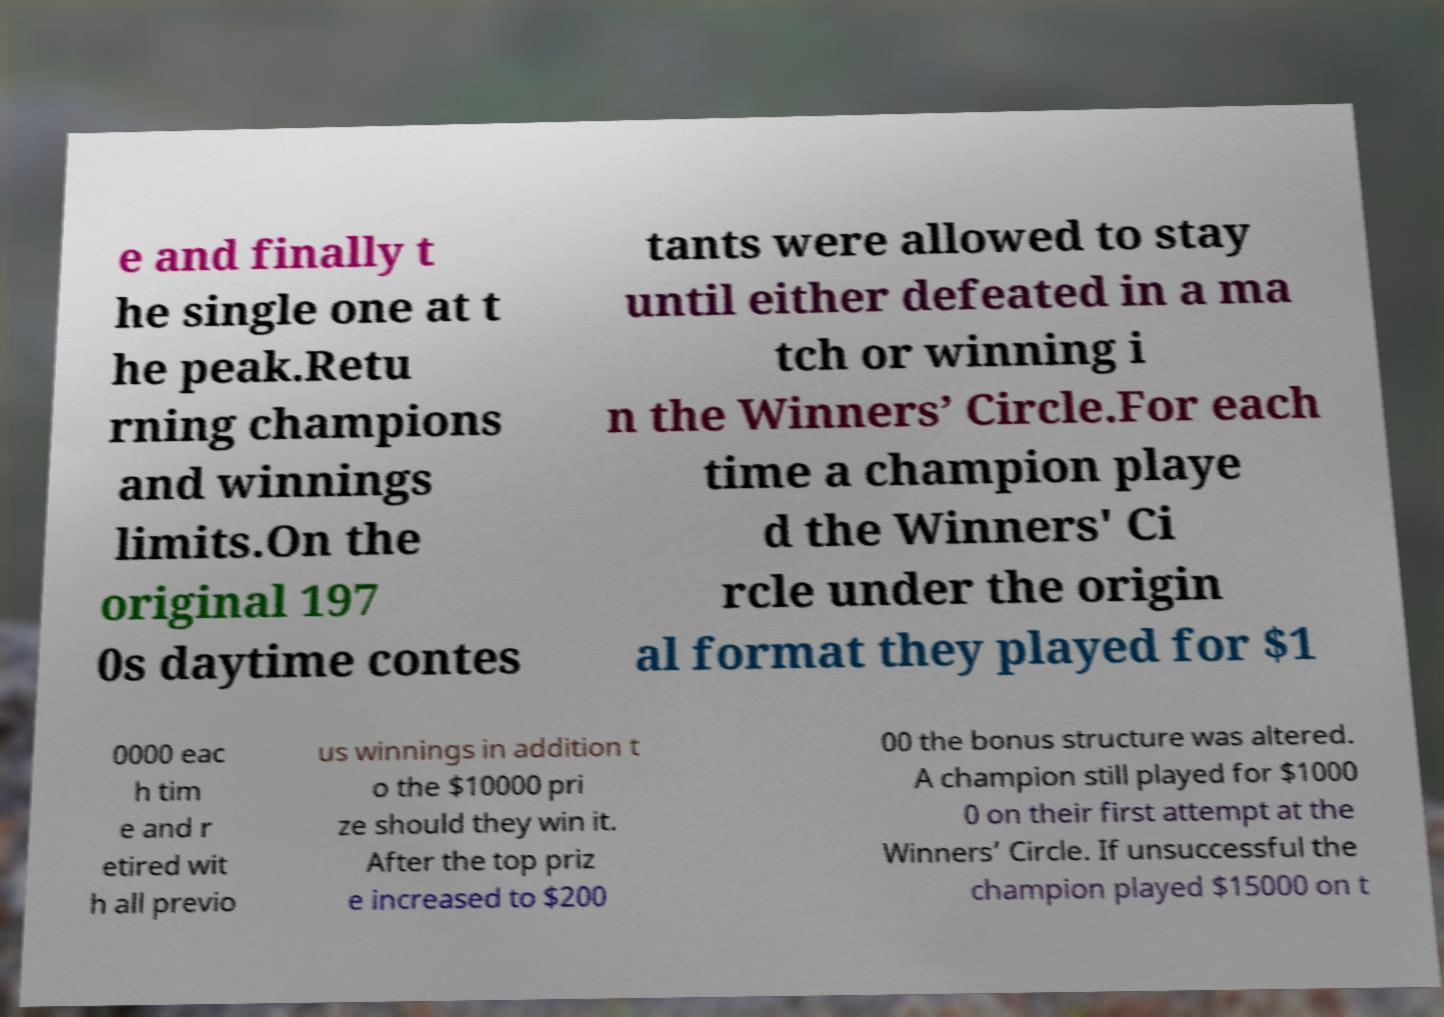Could you extract and type out the text from this image? e and finally t he single one at t he peak.Retu rning champions and winnings limits.On the original 197 0s daytime contes tants were allowed to stay until either defeated in a ma tch or winning i n the Winners’ Circle.For each time a champion playe d the Winners' Ci rcle under the origin al format they played for $1 0000 eac h tim e and r etired wit h all previo us winnings in addition t o the $10000 pri ze should they win it. After the top priz e increased to $200 00 the bonus structure was altered. A champion still played for $1000 0 on their first attempt at the Winners’ Circle. If unsuccessful the champion played $15000 on t 